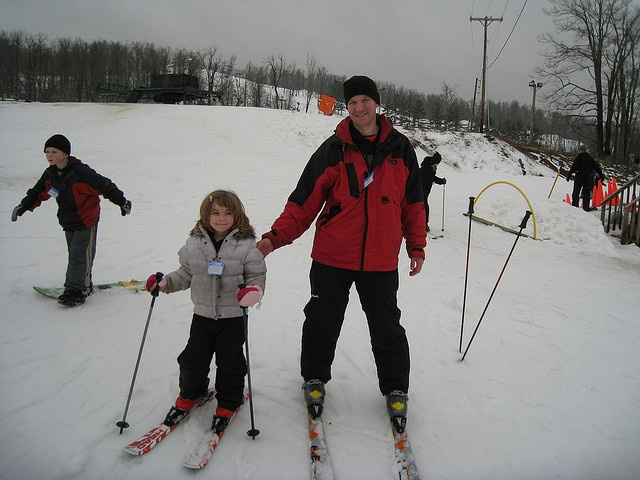Describe the objects in this image and their specific colors. I can see people in gray, black, and maroon tones, people in gray, black, and maroon tones, people in gray, black, maroon, and darkgray tones, skis in gray, black, and maroon tones, and skis in gray, black, and maroon tones in this image. 